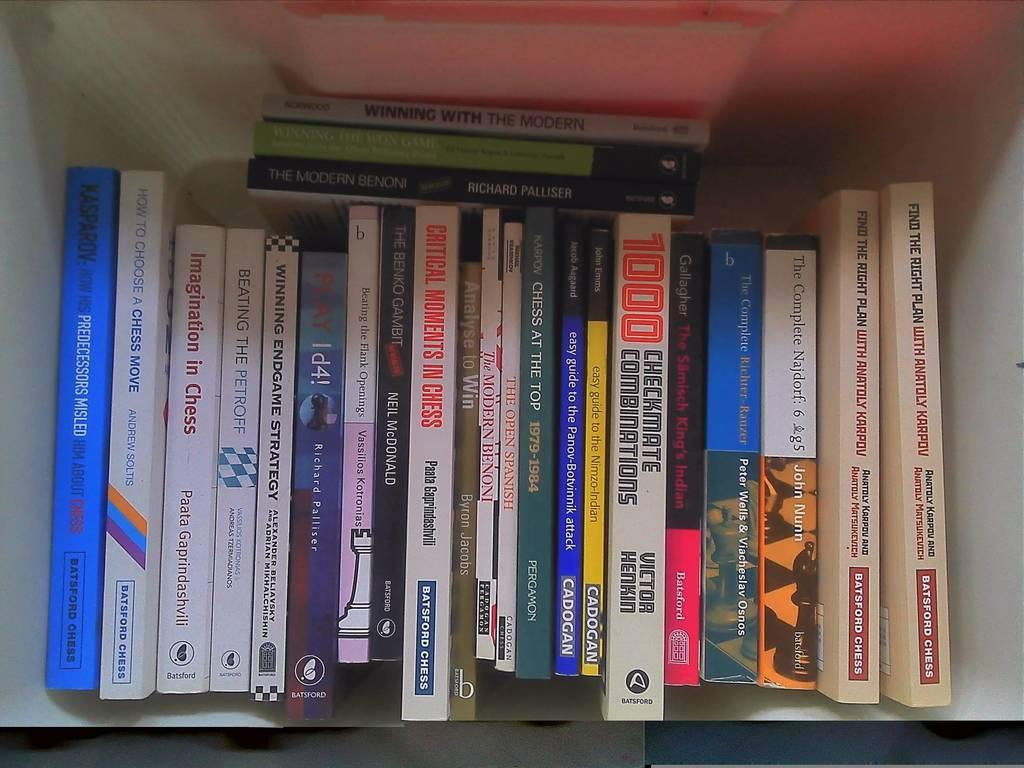Provide a one-sentence caption for the provided image. The book "The Modern Benoni" sits on top of several other books on a white shelf. 